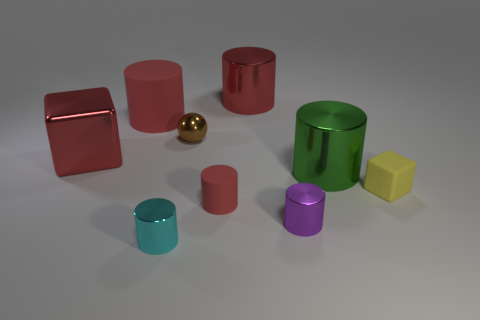What is the material of the red block that is the same size as the green thing?
Offer a terse response. Metal. What number of big red metallic things are right of the rubber cylinder that is behind the red cylinder that is in front of the metallic block?
Offer a terse response. 1. There is a tiny shiny object behind the tiny red cylinder; is its color the same as the shiny cylinder behind the shiny cube?
Your response must be concise. No. What color is the thing that is both behind the tiny brown shiny object and on the right side of the small cyan cylinder?
Offer a terse response. Red. How many rubber blocks are the same size as the cyan object?
Offer a terse response. 1. What shape is the red metallic thing to the left of the small cyan shiny cylinder to the left of the small yellow matte thing?
Give a very brief answer. Cube. What is the shape of the red object that is in front of the metal thing that is left of the tiny metallic cylinder to the left of the tiny red rubber cylinder?
Offer a very short reply. Cylinder. How many other big rubber objects have the same shape as the yellow rubber thing?
Your answer should be compact. 0. There is a small rubber thing that is on the left side of the yellow thing; what number of big red metallic objects are on the right side of it?
Provide a short and direct response. 1. How many matte objects are either cylinders or purple cylinders?
Your answer should be very brief. 2. 